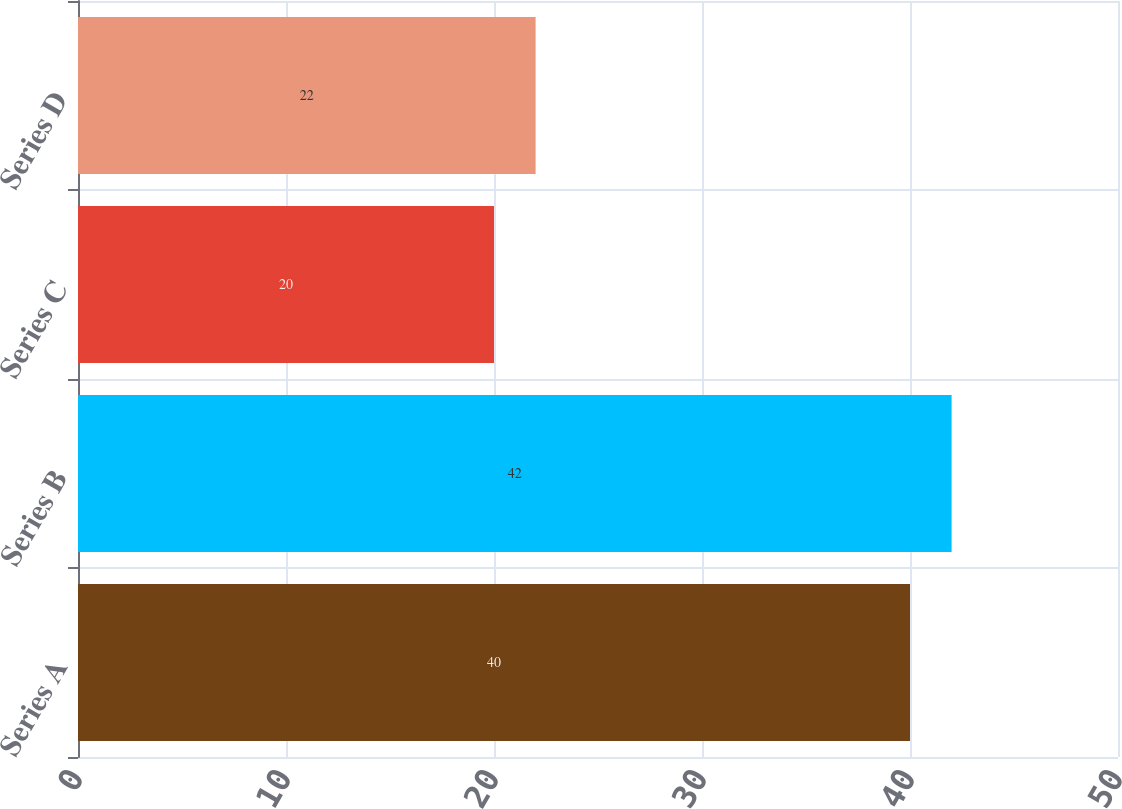<chart> <loc_0><loc_0><loc_500><loc_500><bar_chart><fcel>Series A<fcel>Series B<fcel>Series C<fcel>Series D<nl><fcel>40<fcel>42<fcel>20<fcel>22<nl></chart> 